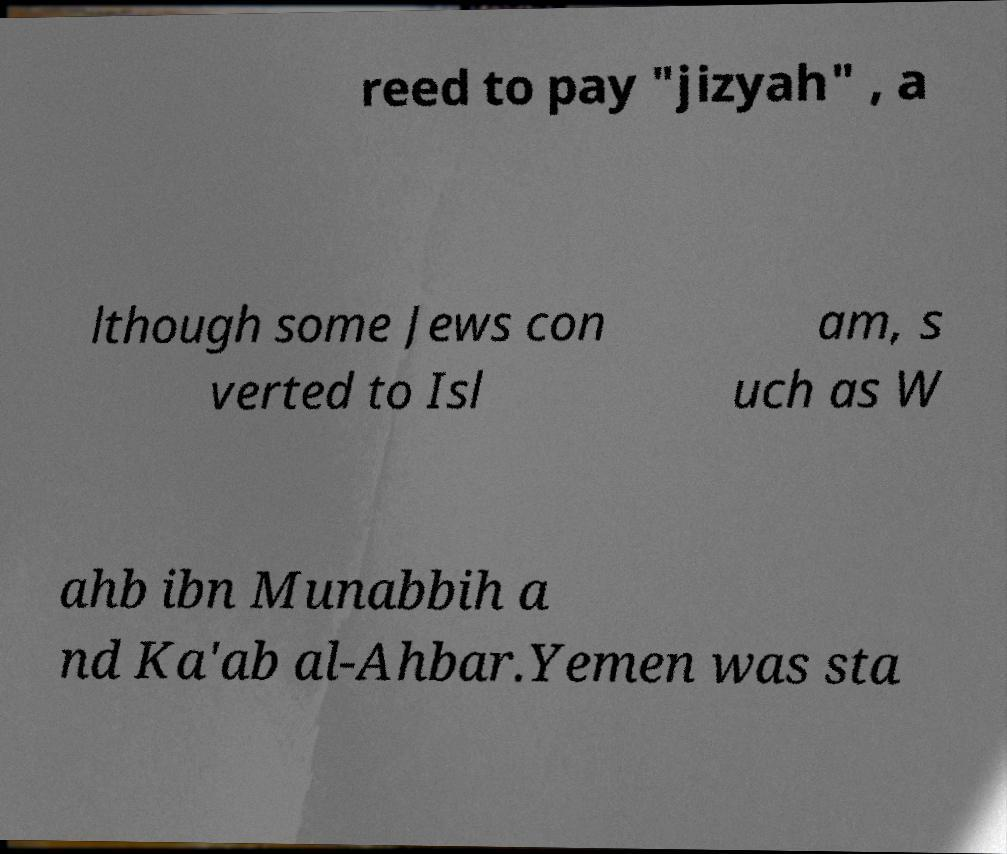For documentation purposes, I need the text within this image transcribed. Could you provide that? reed to pay "jizyah" , a lthough some Jews con verted to Isl am, s uch as W ahb ibn Munabbih a nd Ka'ab al-Ahbar.Yemen was sta 